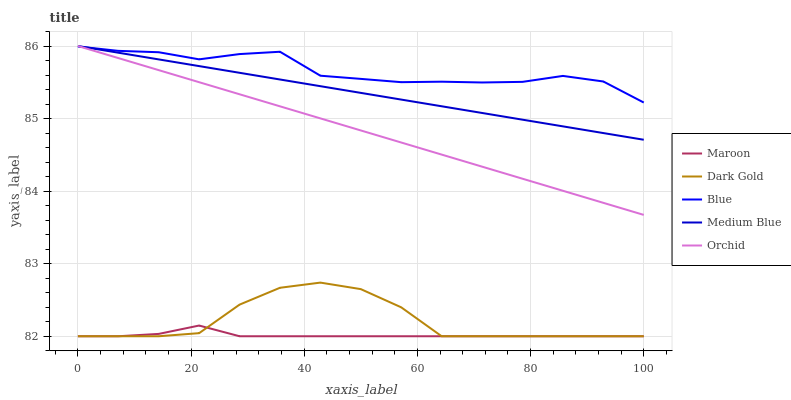Does Maroon have the minimum area under the curve?
Answer yes or no. Yes. Does Blue have the maximum area under the curve?
Answer yes or no. Yes. Does Orchid have the minimum area under the curve?
Answer yes or no. No. Does Orchid have the maximum area under the curve?
Answer yes or no. No. Is Orchid the smoothest?
Answer yes or no. Yes. Is Dark Gold the roughest?
Answer yes or no. Yes. Is Medium Blue the smoothest?
Answer yes or no. No. Is Medium Blue the roughest?
Answer yes or no. No. Does Maroon have the lowest value?
Answer yes or no. Yes. Does Orchid have the lowest value?
Answer yes or no. No. Does Medium Blue have the highest value?
Answer yes or no. Yes. Does Maroon have the highest value?
Answer yes or no. No. Is Dark Gold less than Medium Blue?
Answer yes or no. Yes. Is Blue greater than Maroon?
Answer yes or no. Yes. Does Orchid intersect Blue?
Answer yes or no. Yes. Is Orchid less than Blue?
Answer yes or no. No. Is Orchid greater than Blue?
Answer yes or no. No. Does Dark Gold intersect Medium Blue?
Answer yes or no. No. 